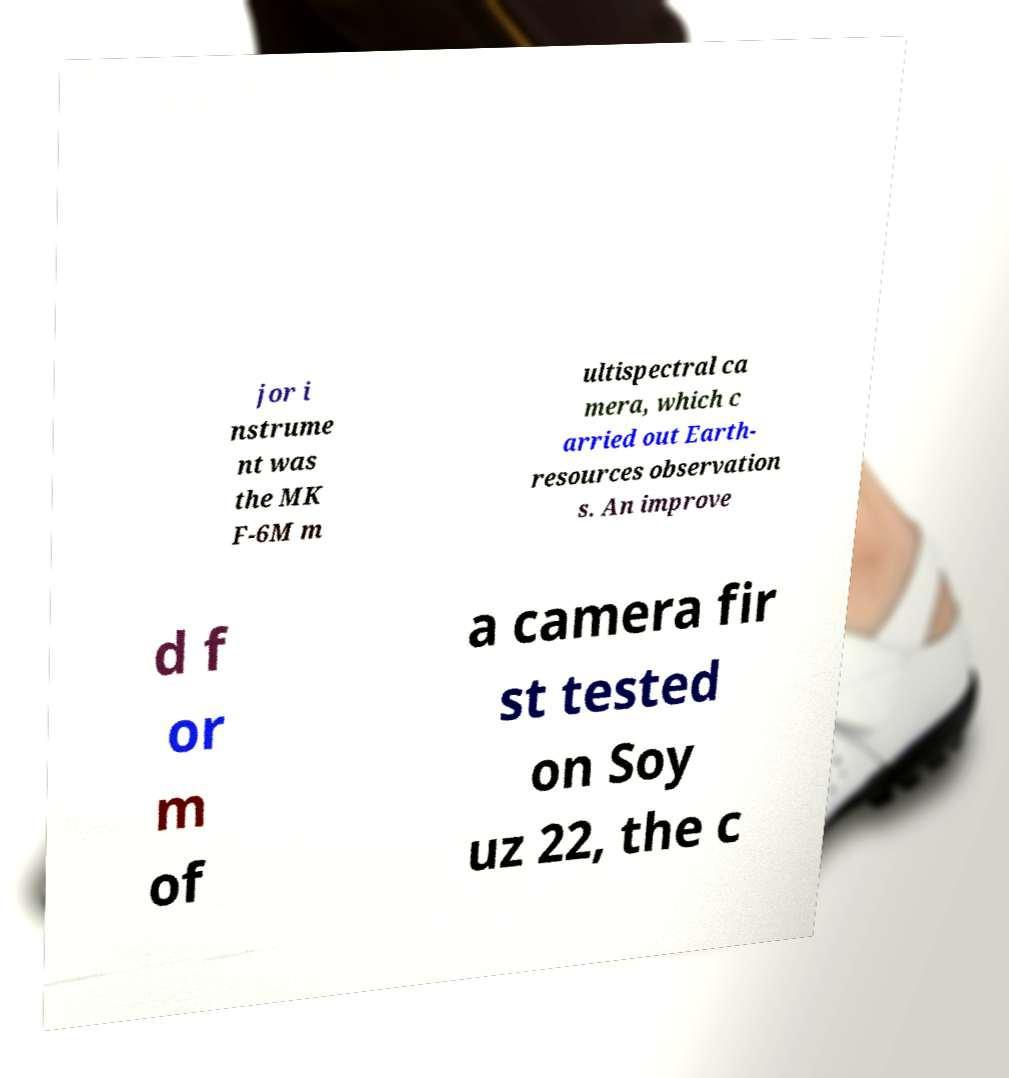I need the written content from this picture converted into text. Can you do that? jor i nstrume nt was the MK F-6M m ultispectral ca mera, which c arried out Earth- resources observation s. An improve d f or m of a camera fir st tested on Soy uz 22, the c 